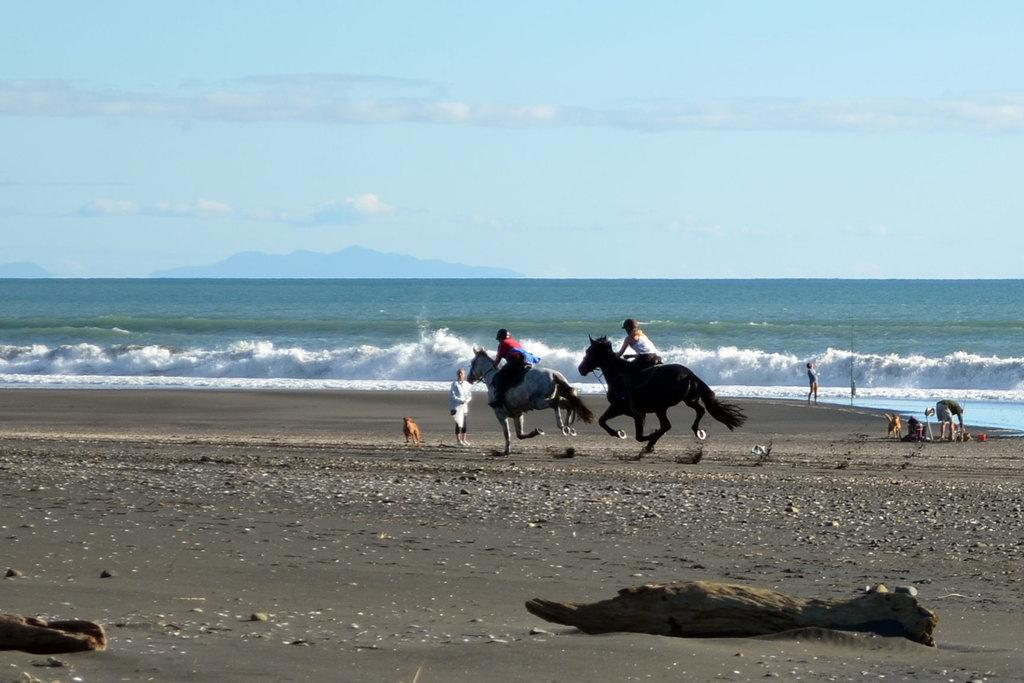How many people are in the image? There are two persons in the image. What are the persons doing in the image? The persons are riding horses. What can be seen in the background of the image? There is water visible in the image. What is the weather like in the image? The sky is sunny in the image. What type of sponge is being used by the beggar in the image? There is no beggar or sponge present in the image. What type of war is depicted in the image? There is no war depicted in the image; it features two persons riding horses. 